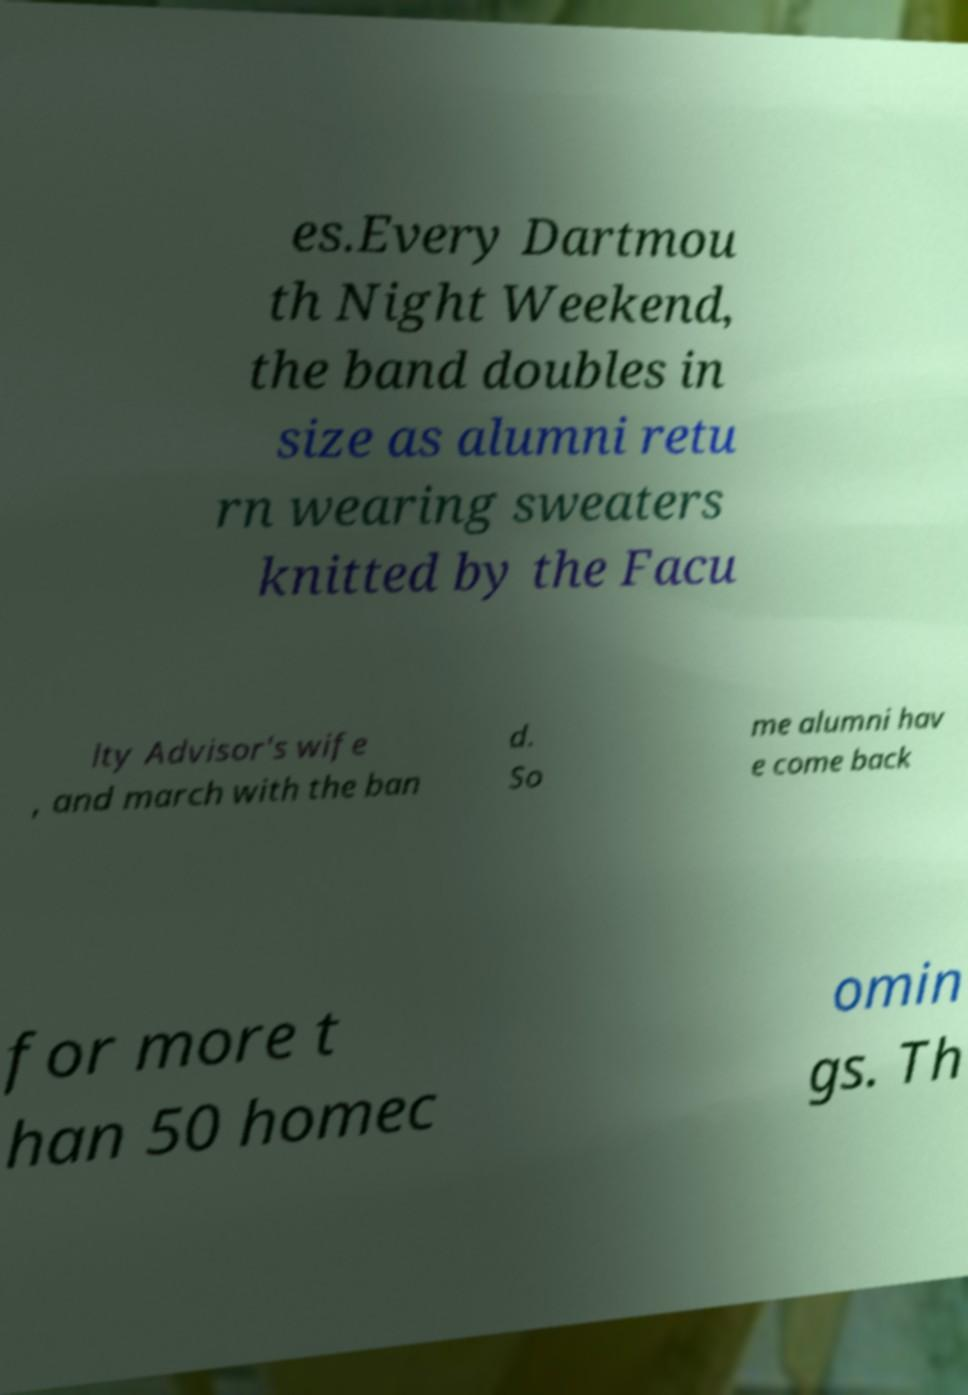Can you accurately transcribe the text from the provided image for me? es.Every Dartmou th Night Weekend, the band doubles in size as alumni retu rn wearing sweaters knitted by the Facu lty Advisor's wife , and march with the ban d. So me alumni hav e come back for more t han 50 homec omin gs. Th 